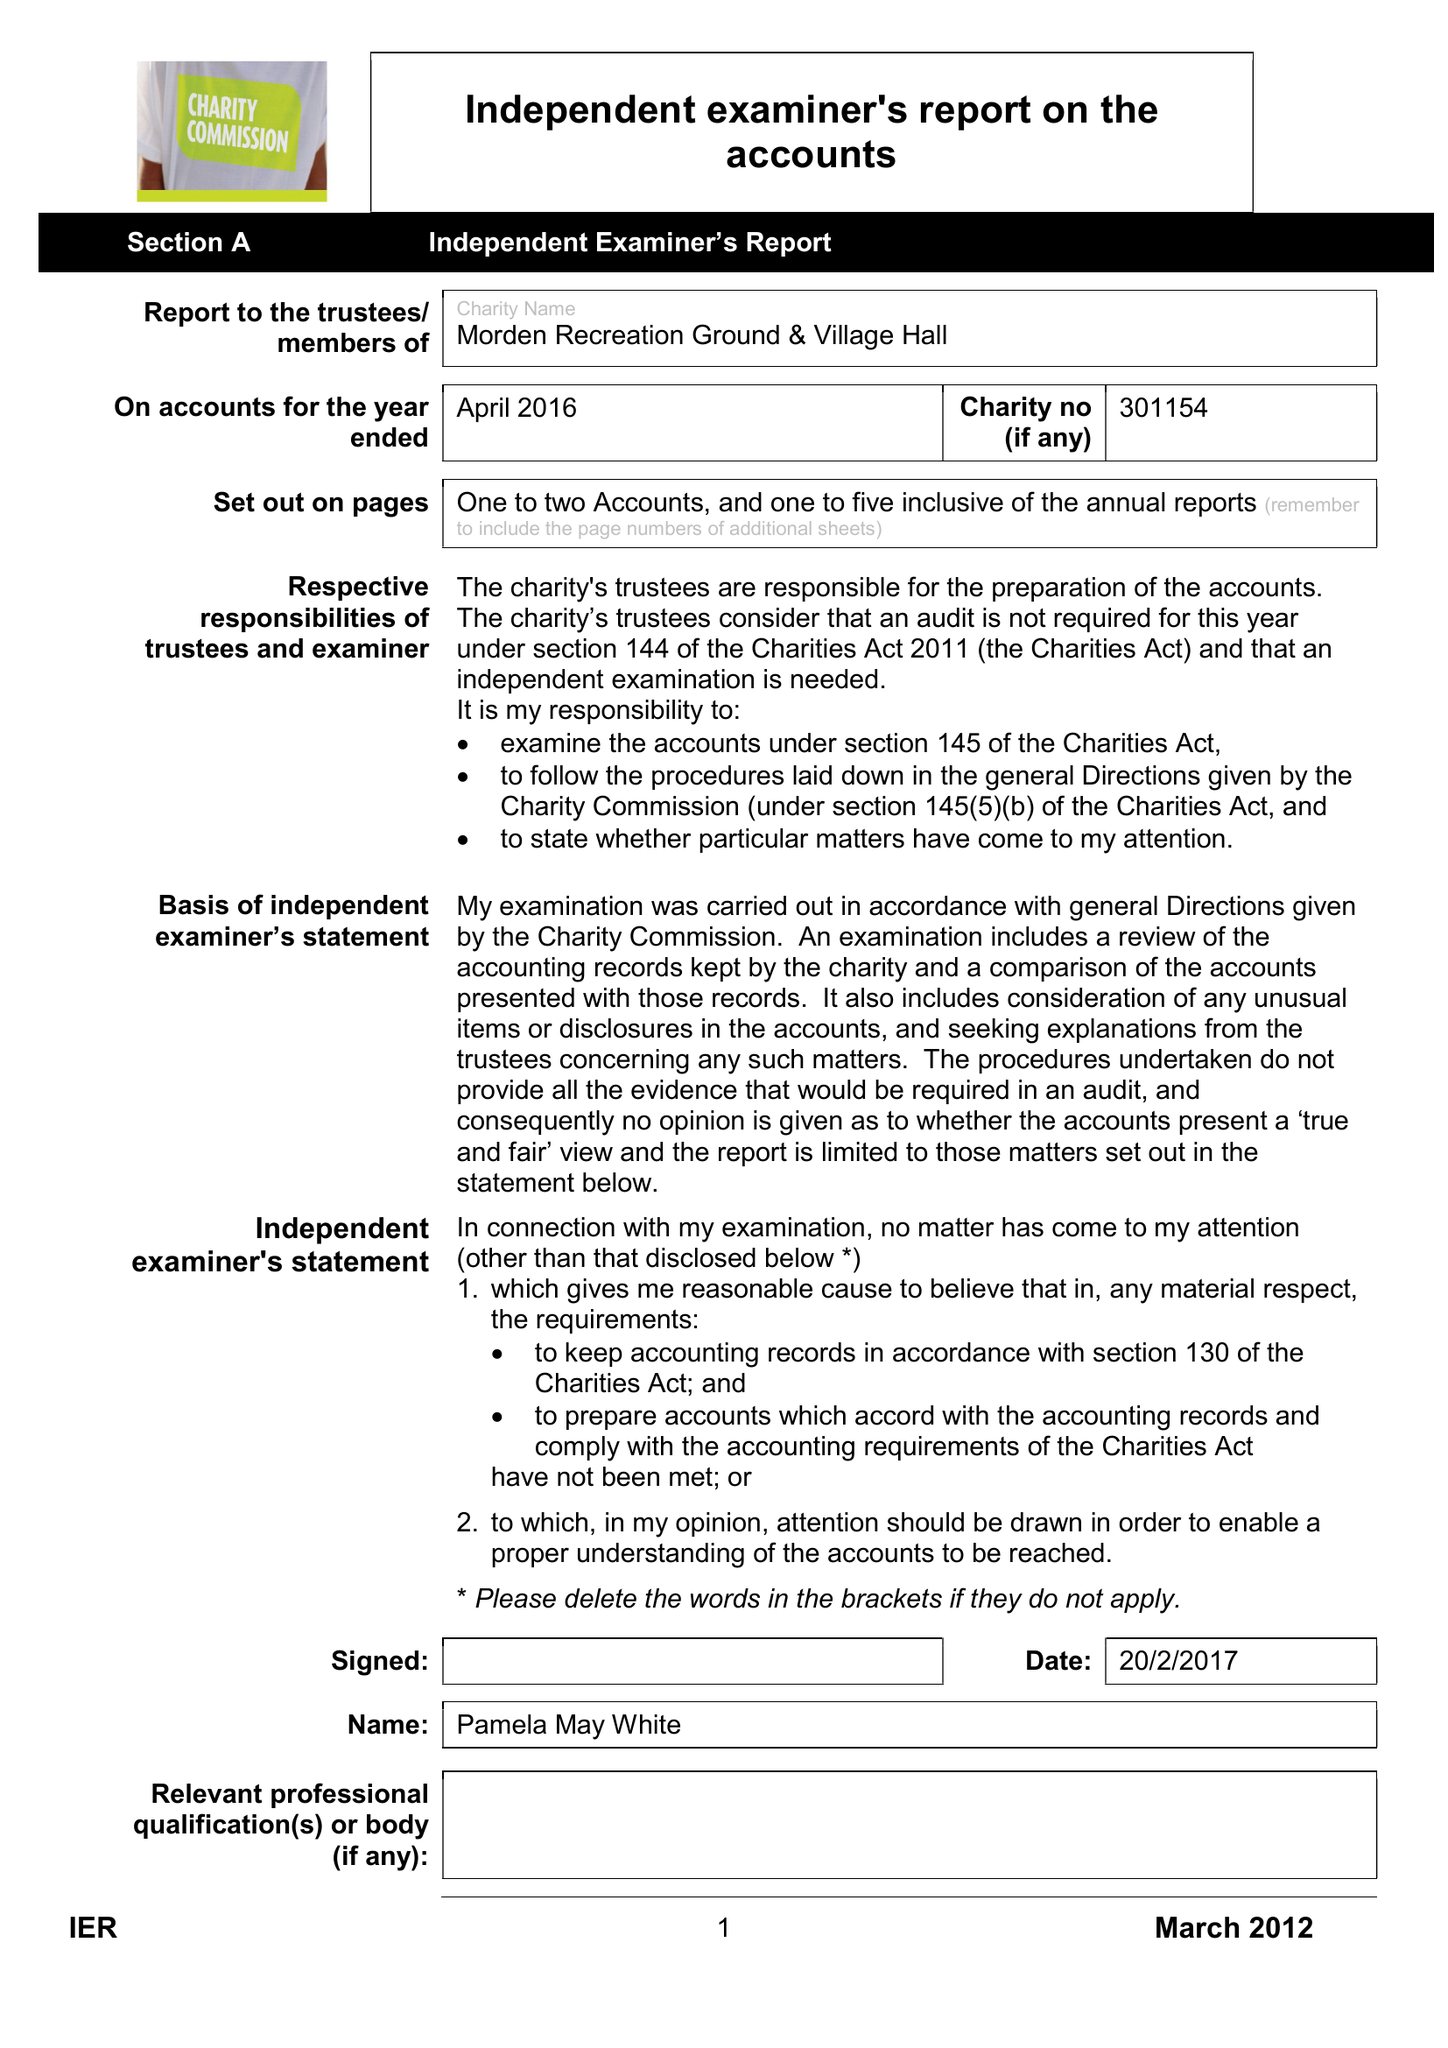What is the value for the address__post_town?
Answer the question using a single word or phrase. WAREHAM 